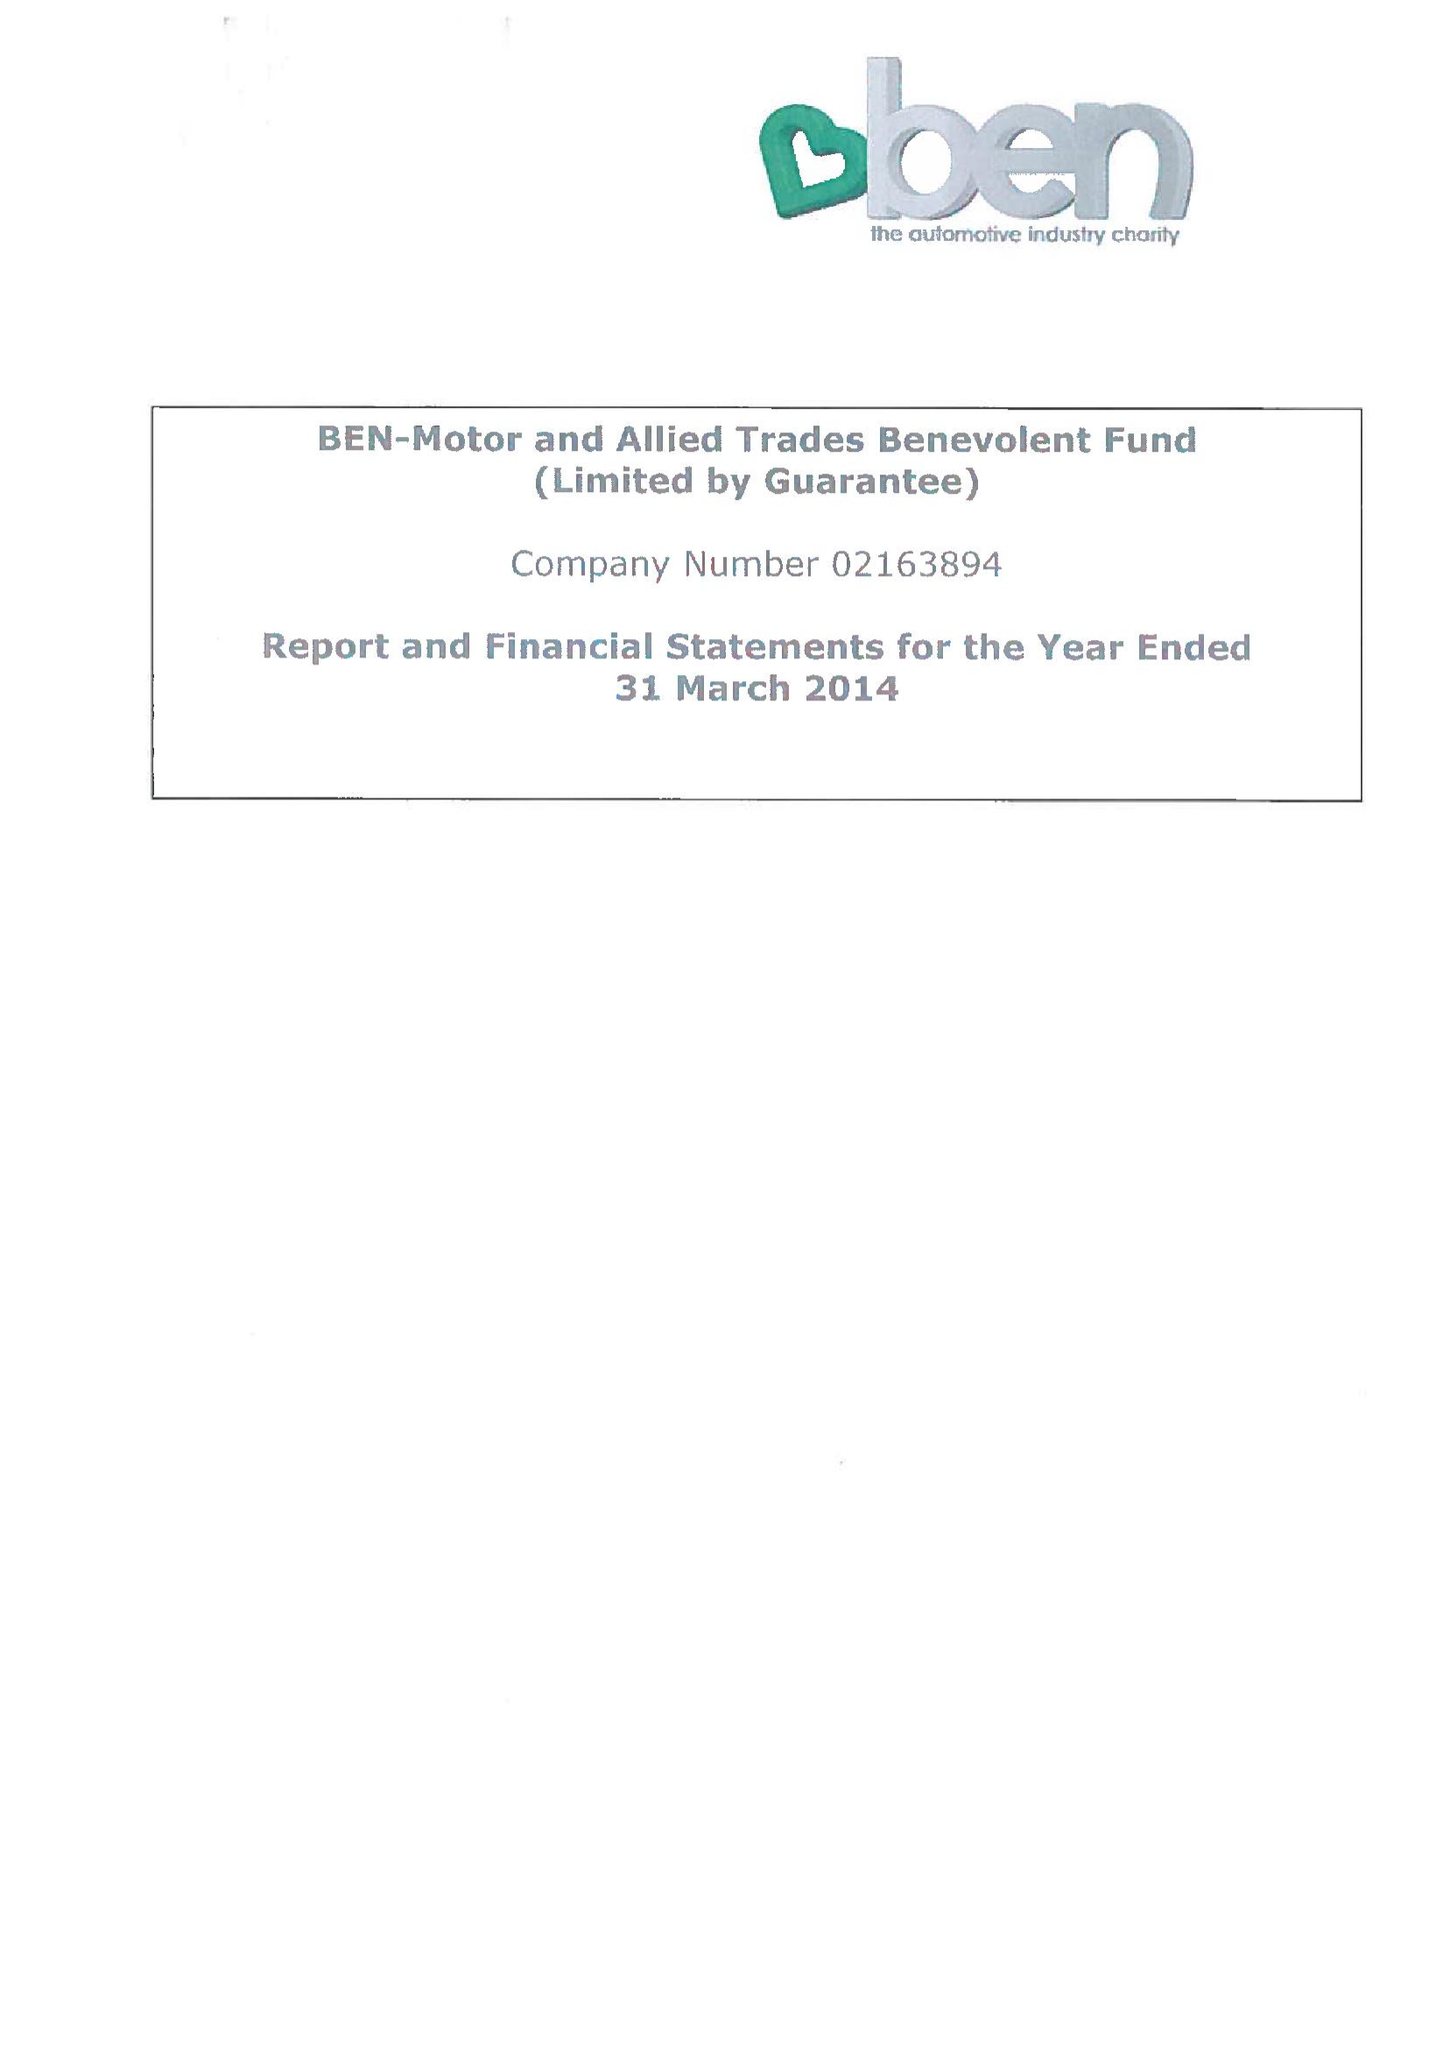What is the value for the income_annually_in_british_pounds?
Answer the question using a single word or phrase. 13445013.00 